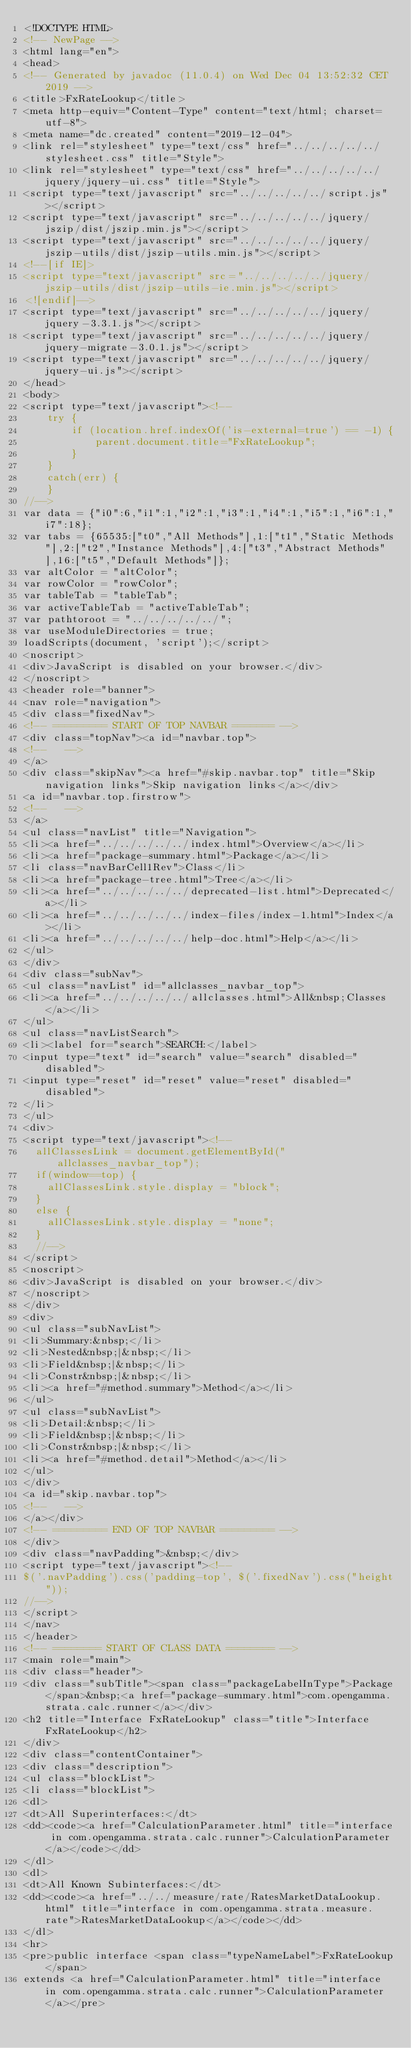Convert code to text. <code><loc_0><loc_0><loc_500><loc_500><_HTML_><!DOCTYPE HTML>
<!-- NewPage -->
<html lang="en">
<head>
<!-- Generated by javadoc (11.0.4) on Wed Dec 04 13:52:32 CET 2019 -->
<title>FxRateLookup</title>
<meta http-equiv="Content-Type" content="text/html; charset=utf-8">
<meta name="dc.created" content="2019-12-04">
<link rel="stylesheet" type="text/css" href="../../../../../stylesheet.css" title="Style">
<link rel="stylesheet" type="text/css" href="../../../../../jquery/jquery-ui.css" title="Style">
<script type="text/javascript" src="../../../../../script.js"></script>
<script type="text/javascript" src="../../../../../jquery/jszip/dist/jszip.min.js"></script>
<script type="text/javascript" src="../../../../../jquery/jszip-utils/dist/jszip-utils.min.js"></script>
<!--[if IE]>
<script type="text/javascript" src="../../../../../jquery/jszip-utils/dist/jszip-utils-ie.min.js"></script>
<![endif]-->
<script type="text/javascript" src="../../../../../jquery/jquery-3.3.1.js"></script>
<script type="text/javascript" src="../../../../../jquery/jquery-migrate-3.0.1.js"></script>
<script type="text/javascript" src="../../../../../jquery/jquery-ui.js"></script>
</head>
<body>
<script type="text/javascript"><!--
    try {
        if (location.href.indexOf('is-external=true') == -1) {
            parent.document.title="FxRateLookup";
        }
    }
    catch(err) {
    }
//-->
var data = {"i0":6,"i1":1,"i2":1,"i3":1,"i4":1,"i5":1,"i6":1,"i7":18};
var tabs = {65535:["t0","All Methods"],1:["t1","Static Methods"],2:["t2","Instance Methods"],4:["t3","Abstract Methods"],16:["t5","Default Methods"]};
var altColor = "altColor";
var rowColor = "rowColor";
var tableTab = "tableTab";
var activeTableTab = "activeTableTab";
var pathtoroot = "../../../../../";
var useModuleDirectories = true;
loadScripts(document, 'script');</script>
<noscript>
<div>JavaScript is disabled on your browser.</div>
</noscript>
<header role="banner">
<nav role="navigation">
<div class="fixedNav">
<!-- ========= START OF TOP NAVBAR ======= -->
<div class="topNav"><a id="navbar.top">
<!--   -->
</a>
<div class="skipNav"><a href="#skip.navbar.top" title="Skip navigation links">Skip navigation links</a></div>
<a id="navbar.top.firstrow">
<!--   -->
</a>
<ul class="navList" title="Navigation">
<li><a href="../../../../../index.html">Overview</a></li>
<li><a href="package-summary.html">Package</a></li>
<li class="navBarCell1Rev">Class</li>
<li><a href="package-tree.html">Tree</a></li>
<li><a href="../../../../../deprecated-list.html">Deprecated</a></li>
<li><a href="../../../../../index-files/index-1.html">Index</a></li>
<li><a href="../../../../../help-doc.html">Help</a></li>
</ul>
</div>
<div class="subNav">
<ul class="navList" id="allclasses_navbar_top">
<li><a href="../../../../../allclasses.html">All&nbsp;Classes</a></li>
</ul>
<ul class="navListSearch">
<li><label for="search">SEARCH:</label>
<input type="text" id="search" value="search" disabled="disabled">
<input type="reset" id="reset" value="reset" disabled="disabled">
</li>
</ul>
<div>
<script type="text/javascript"><!--
  allClassesLink = document.getElementById("allclasses_navbar_top");
  if(window==top) {
    allClassesLink.style.display = "block";
  }
  else {
    allClassesLink.style.display = "none";
  }
  //-->
</script>
<noscript>
<div>JavaScript is disabled on your browser.</div>
</noscript>
</div>
<div>
<ul class="subNavList">
<li>Summary:&nbsp;</li>
<li>Nested&nbsp;|&nbsp;</li>
<li>Field&nbsp;|&nbsp;</li>
<li>Constr&nbsp;|&nbsp;</li>
<li><a href="#method.summary">Method</a></li>
</ul>
<ul class="subNavList">
<li>Detail:&nbsp;</li>
<li>Field&nbsp;|&nbsp;</li>
<li>Constr&nbsp;|&nbsp;</li>
<li><a href="#method.detail">Method</a></li>
</ul>
</div>
<a id="skip.navbar.top">
<!--   -->
</a></div>
<!-- ========= END OF TOP NAVBAR ========= -->
</div>
<div class="navPadding">&nbsp;</div>
<script type="text/javascript"><!--
$('.navPadding').css('padding-top', $('.fixedNav').css("height"));
//-->
</script>
</nav>
</header>
<!-- ======== START OF CLASS DATA ======== -->
<main role="main">
<div class="header">
<div class="subTitle"><span class="packageLabelInType">Package</span>&nbsp;<a href="package-summary.html">com.opengamma.strata.calc.runner</a></div>
<h2 title="Interface FxRateLookup" class="title">Interface FxRateLookup</h2>
</div>
<div class="contentContainer">
<div class="description">
<ul class="blockList">
<li class="blockList">
<dl>
<dt>All Superinterfaces:</dt>
<dd><code><a href="CalculationParameter.html" title="interface in com.opengamma.strata.calc.runner">CalculationParameter</a></code></dd>
</dl>
<dl>
<dt>All Known Subinterfaces:</dt>
<dd><code><a href="../../measure/rate/RatesMarketDataLookup.html" title="interface in com.opengamma.strata.measure.rate">RatesMarketDataLookup</a></code></dd>
</dl>
<hr>
<pre>public interface <span class="typeNameLabel">FxRateLookup</span>
extends <a href="CalculationParameter.html" title="interface in com.opengamma.strata.calc.runner">CalculationParameter</a></pre></code> 